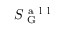<formula> <loc_0><loc_0><loc_500><loc_500>S _ { G } ^ { a l l }</formula> 